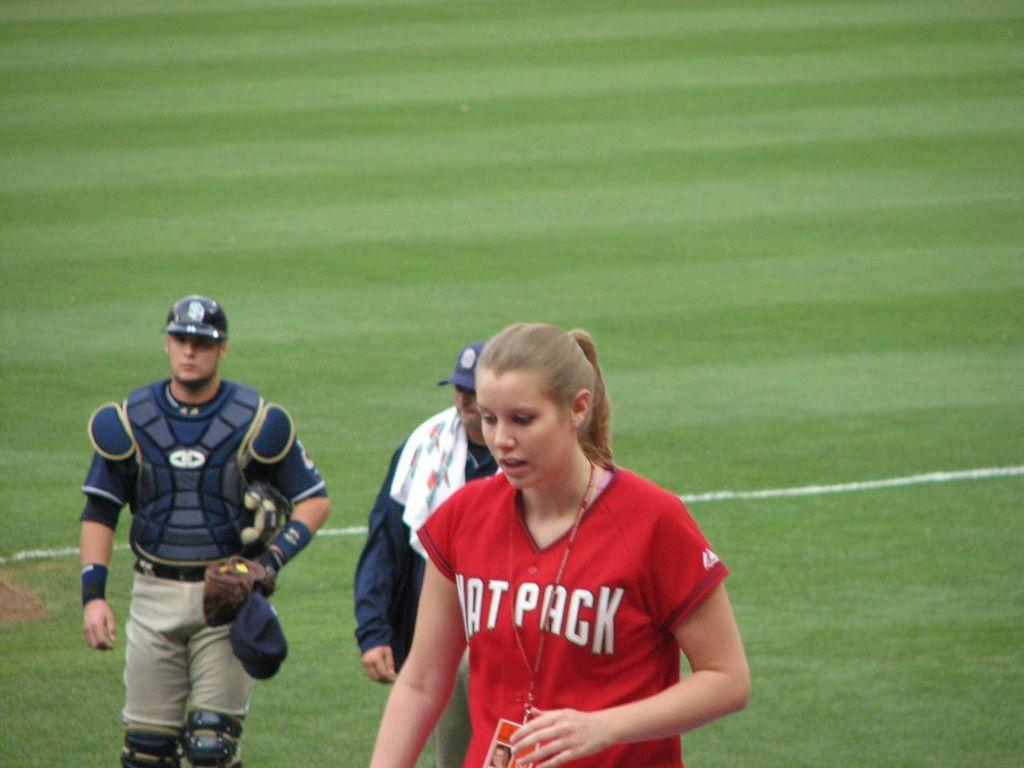Provide a one-sentence caption for the provided image. A woman with the word "pack" on her shirt is wearing an identification lanyard around her neck. 